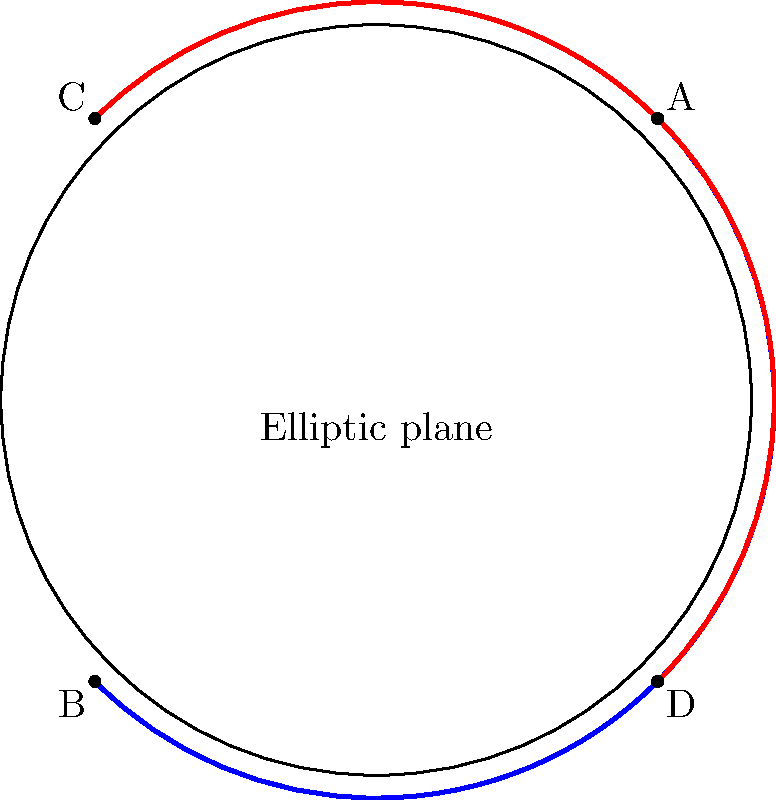In the context of promoting a TV show about mathematical mysteries, how would you explain the concept of parallel lines in elliptic geometry to a vlogger, using this illustration as a visual aid? To explain parallel lines in elliptic geometry to a vlogger promoting a TV show about mathematical mysteries, we can break it down into steps:

1. Introduction: In elliptic geometry, we consider the surface of a sphere instead of a flat plane. This illustration shows a 2D representation of the elliptic plane.

2. Definition of lines: In elliptic geometry, "lines" are actually great circles on the sphere. In our 2D representation, they appear as arcs.

3. Parallel lines: Unlike in Euclidean geometry, parallel lines don't exist in elliptic geometry. All "lines" (great circles) intersect at two points.

4. Visual explanation: In the diagram, we see two "lines" represented by the blue and red arcs. These arcs intersect at two points: A and B for one pair, and C and D for the other.

5. Key difference: In Euclidean geometry, parallel lines never intersect. In elliptic geometry, all lines eventually intersect.

6. Real-world example: This concept is similar to how longitude lines on a globe all intersect at the poles, even though they may appear parallel near the equator.

7. TV show connection: This mind-bending concept could be an intriguing mystery for the show, challenging viewers' understanding of geometry and space.

By explaining these points, we can help the vlogger create engaging content that promotes the TV show while educating their audience about non-Euclidean geometry.
Answer: In elliptic geometry, all lines (great circles) intersect, so parallel lines don't exist. 